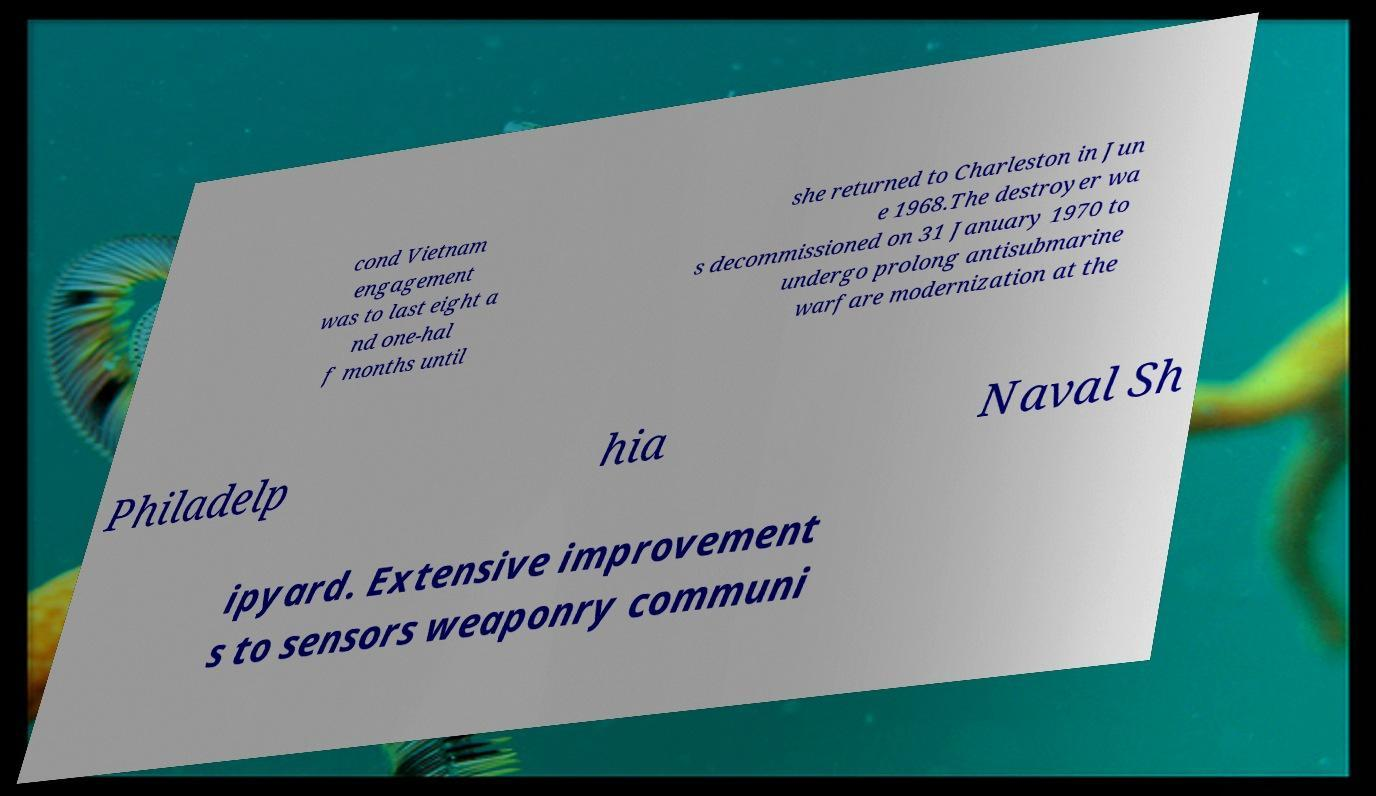Please identify and transcribe the text found in this image. cond Vietnam engagement was to last eight a nd one-hal f months until she returned to Charleston in Jun e 1968.The destroyer wa s decommissioned on 31 January 1970 to undergo prolong antisubmarine warfare modernization at the Philadelp hia Naval Sh ipyard. Extensive improvement s to sensors weaponry communi 